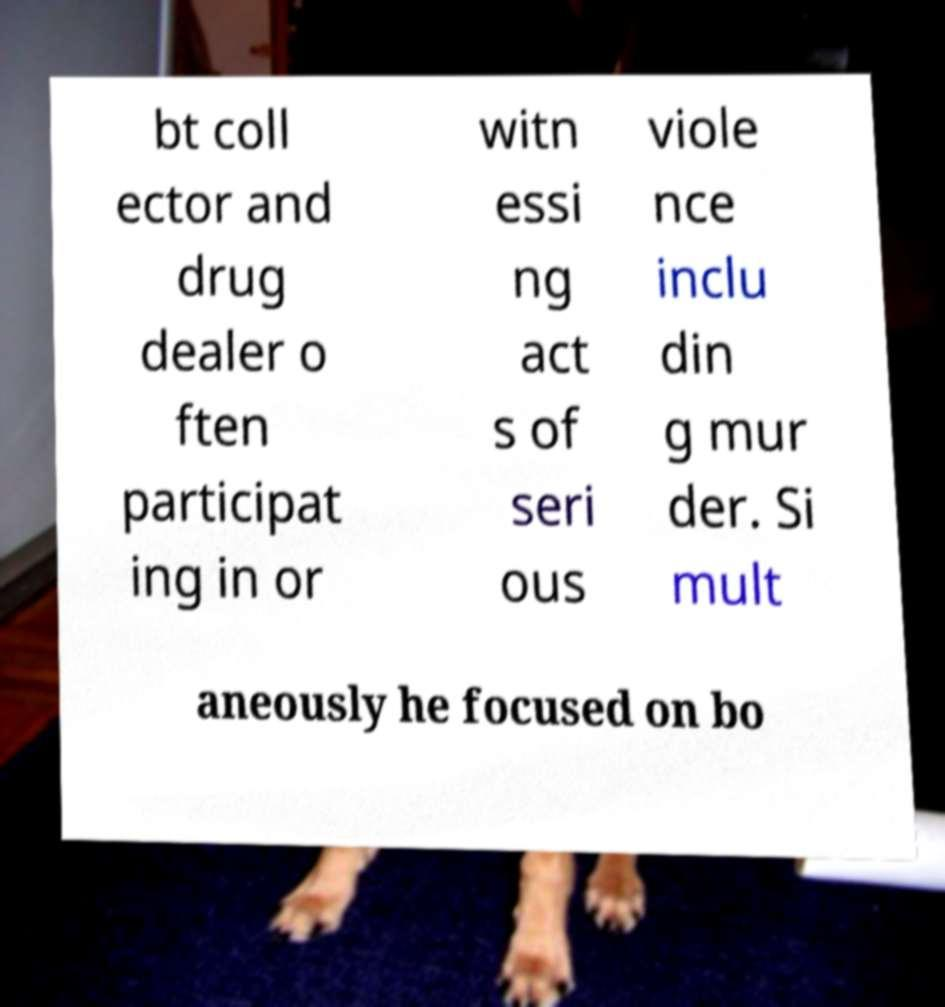There's text embedded in this image that I need extracted. Can you transcribe it verbatim? bt coll ector and drug dealer o ften participat ing in or witn essi ng act s of seri ous viole nce inclu din g mur der. Si mult aneously he focused on bo 